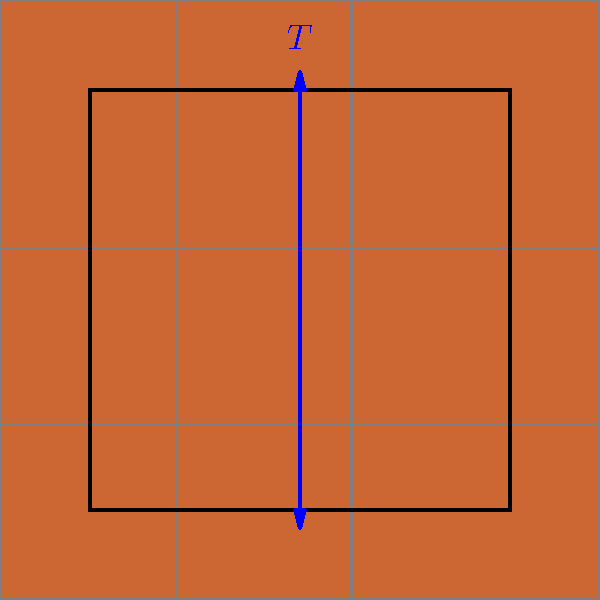In the mosaic tile pattern shown above, what is the period of the translational symmetry $T$ in terms of tile width? To determine the period of translational symmetry, we need to follow these steps:

1. Observe the repeating pattern: The mosaic consists of identical square tiles arranged in a grid.

2. Identify the translation vector: The blue arrow labeled $T$ represents the translation vector we're analyzing.

3. Determine the direction of translation: The arrow points vertically, indicating a translation in the y-direction.

4. Count the number of tiles: The translation covers exactly one tile in the vertical direction.

5. Relate to tile width: Since the tiles are square, the height of one tile is equal to its width.

6. Conclude: The period of the translational symmetry $T$ is equal to the width of one tile.

This type of symmetry is fundamental in bricklaying, where patterns often repeat at regular intervals, creating a visually pleasing and structurally sound arrangement.
Answer: 1 tile width 